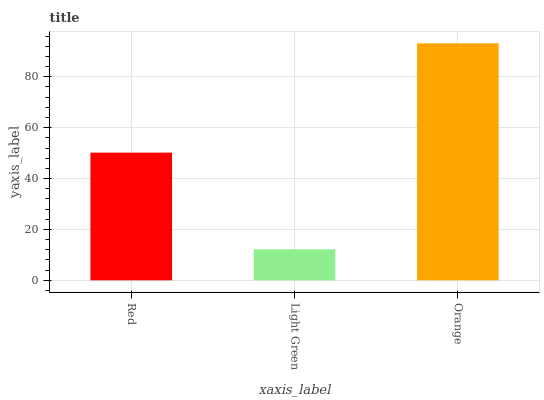Is Orange the minimum?
Answer yes or no. No. Is Light Green the maximum?
Answer yes or no. No. Is Orange greater than Light Green?
Answer yes or no. Yes. Is Light Green less than Orange?
Answer yes or no. Yes. Is Light Green greater than Orange?
Answer yes or no. No. Is Orange less than Light Green?
Answer yes or no. No. Is Red the high median?
Answer yes or no. Yes. Is Red the low median?
Answer yes or no. Yes. Is Orange the high median?
Answer yes or no. No. Is Light Green the low median?
Answer yes or no. No. 